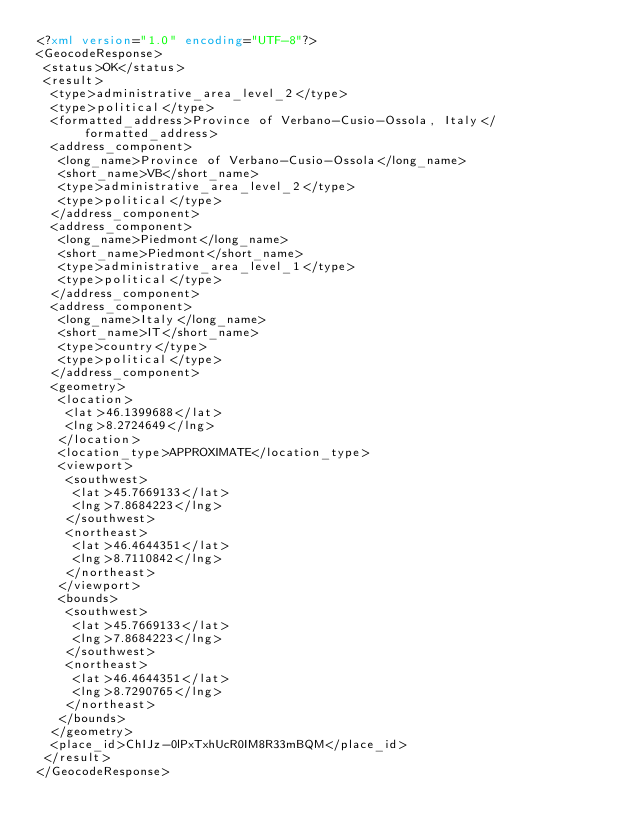Convert code to text. <code><loc_0><loc_0><loc_500><loc_500><_XML_><?xml version="1.0" encoding="UTF-8"?>
<GeocodeResponse>
 <status>OK</status>
 <result>
  <type>administrative_area_level_2</type>
  <type>political</type>
  <formatted_address>Province of Verbano-Cusio-Ossola, Italy</formatted_address>
  <address_component>
   <long_name>Province of Verbano-Cusio-Ossola</long_name>
   <short_name>VB</short_name>
   <type>administrative_area_level_2</type>
   <type>political</type>
  </address_component>
  <address_component>
   <long_name>Piedmont</long_name>
   <short_name>Piedmont</short_name>
   <type>administrative_area_level_1</type>
   <type>political</type>
  </address_component>
  <address_component>
   <long_name>Italy</long_name>
   <short_name>IT</short_name>
   <type>country</type>
   <type>political</type>
  </address_component>
  <geometry>
   <location>
    <lat>46.1399688</lat>
    <lng>8.2724649</lng>
   </location>
   <location_type>APPROXIMATE</location_type>
   <viewport>
    <southwest>
     <lat>45.7669133</lat>
     <lng>7.8684223</lng>
    </southwest>
    <northeast>
     <lat>46.4644351</lat>
     <lng>8.7110842</lng>
    </northeast>
   </viewport>
   <bounds>
    <southwest>
     <lat>45.7669133</lat>
     <lng>7.8684223</lng>
    </southwest>
    <northeast>
     <lat>46.4644351</lat>
     <lng>8.7290765</lng>
    </northeast>
   </bounds>
  </geometry>
  <place_id>ChIJz-0lPxTxhUcR0IM8R33mBQM</place_id>
 </result>
</GeocodeResponse>
</code> 